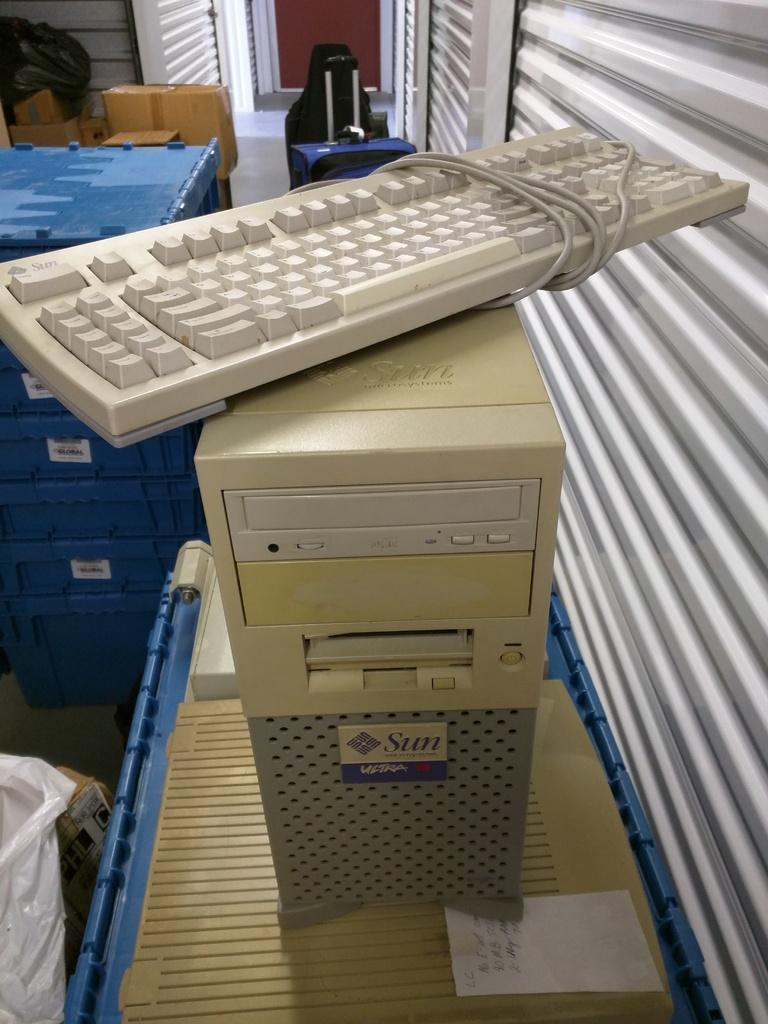What electronic device is visible in the image? There is a keyboard in the image. Where is the keyboard located? The keyboard is on a CPU. What surface is the CPU placed on? The CPU is on a table. What is located beside the table? There is a shutter beside the table. What can be seen on the left side of the image? There are containers on the left side of the image. How many fish are swimming in the cellar in the image? There are no fish or cellar present in the image. 